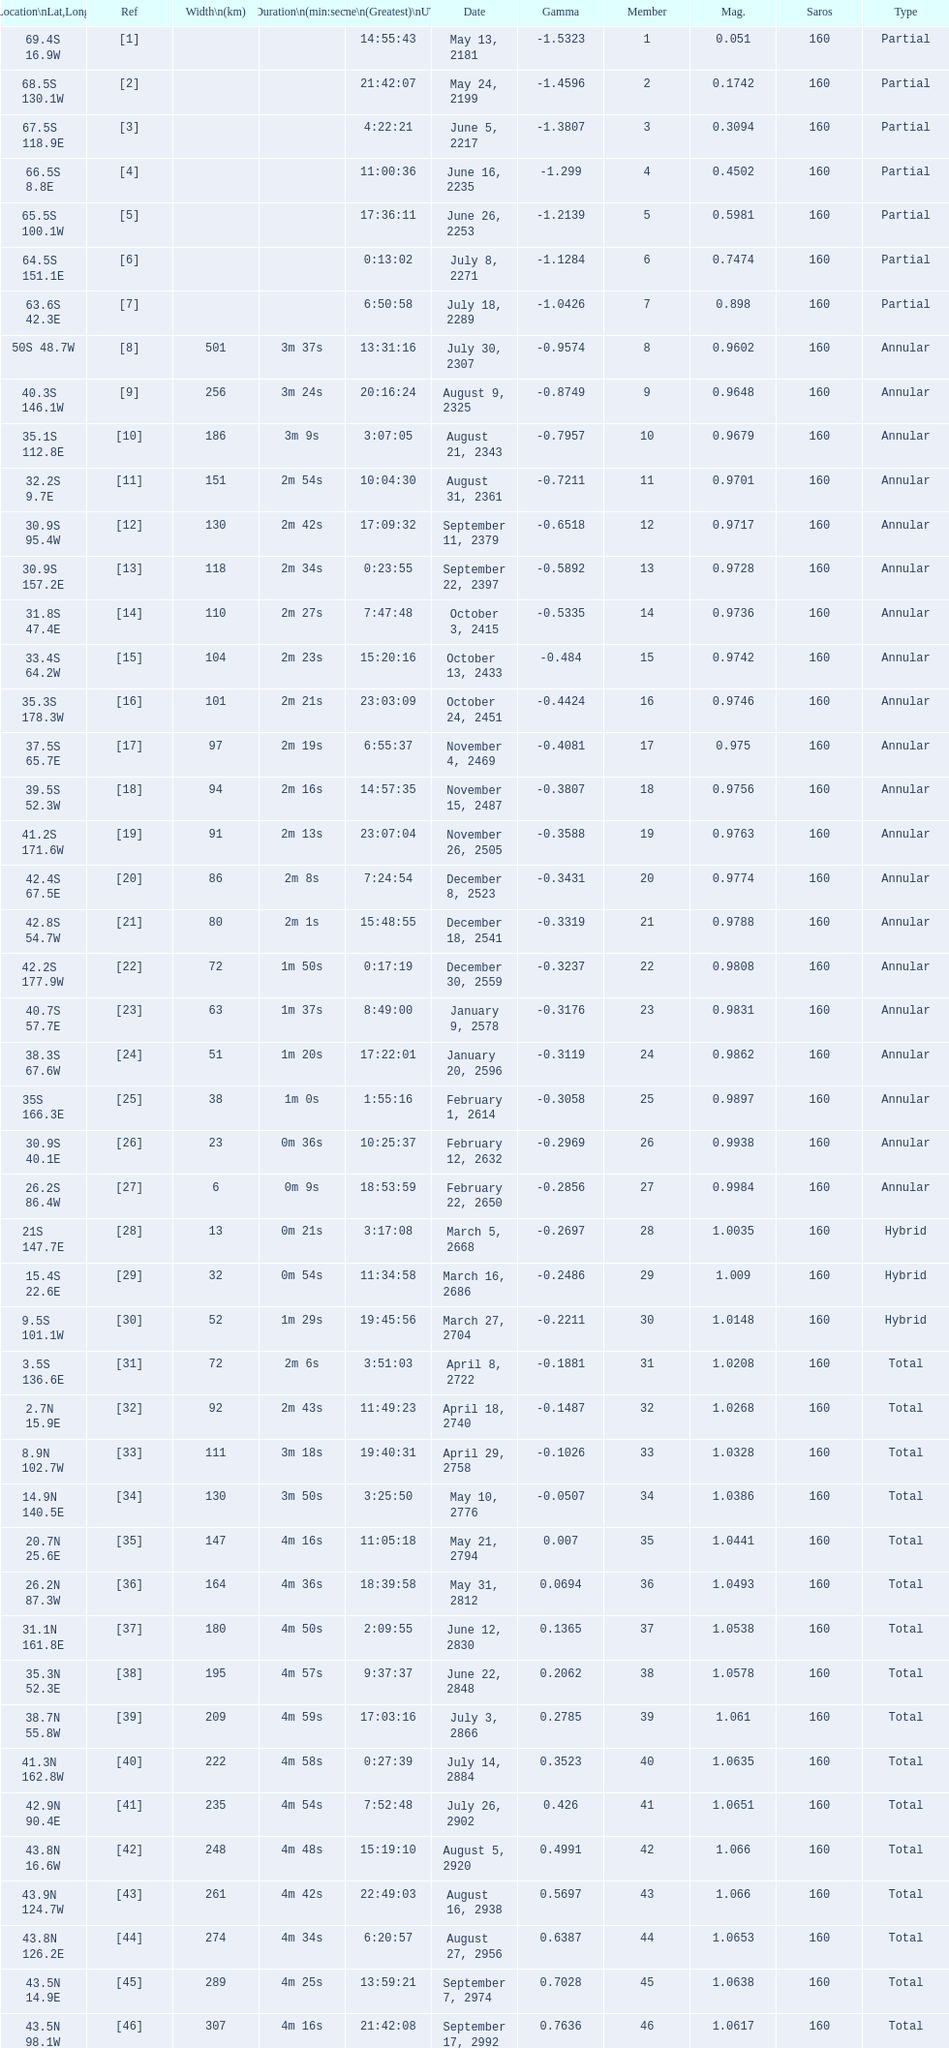How many total events will occur in all? 46. 